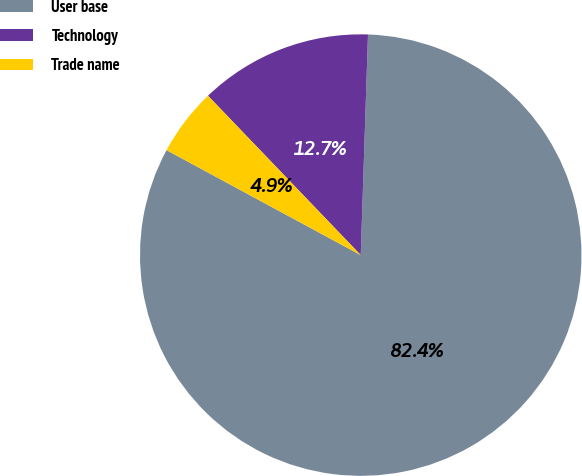<chart> <loc_0><loc_0><loc_500><loc_500><pie_chart><fcel>User base<fcel>Technology<fcel>Trade name<nl><fcel>82.37%<fcel>12.69%<fcel>4.95%<nl></chart> 